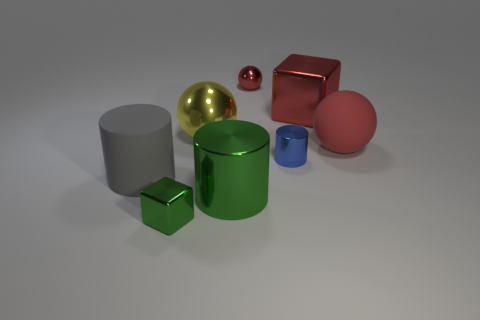Add 1 large red balls. How many objects exist? 9 Subtract all large metal cylinders. How many cylinders are left? 2 Subtract 2 spheres. How many spheres are left? 1 Subtract all red cylinders. How many red spheres are left? 2 Subtract all red balls. How many balls are left? 1 Add 4 small brown objects. How many small brown objects exist? 4 Subtract 1 red cubes. How many objects are left? 7 Subtract all spheres. How many objects are left? 5 Subtract all yellow blocks. Subtract all gray balls. How many blocks are left? 2 Subtract all large yellow balls. Subtract all large gray matte objects. How many objects are left? 6 